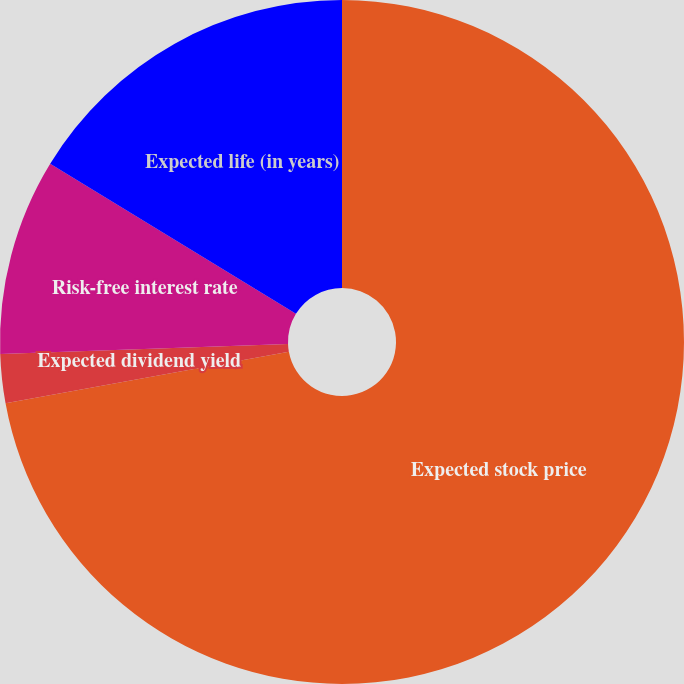Convert chart. <chart><loc_0><loc_0><loc_500><loc_500><pie_chart><fcel>Expected stock price<fcel>Expected dividend yield<fcel>Risk-free interest rate<fcel>Expected life (in years)<nl><fcel>72.13%<fcel>2.31%<fcel>9.29%<fcel>16.27%<nl></chart> 